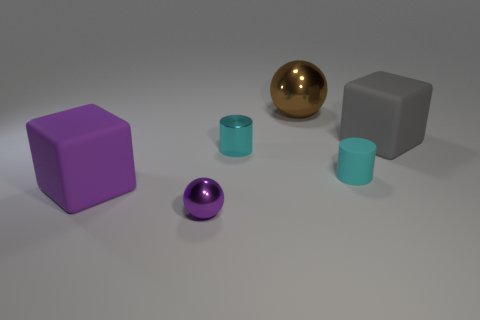Can you tell me about the lighting in this scene? Sure, the scene is lit in a way that casts soft shadows from the objects, suggesting a broad light source. The lack of harsh shadows indicates that the light source may be diffused, pointing to an evenly lit indoor setting. 